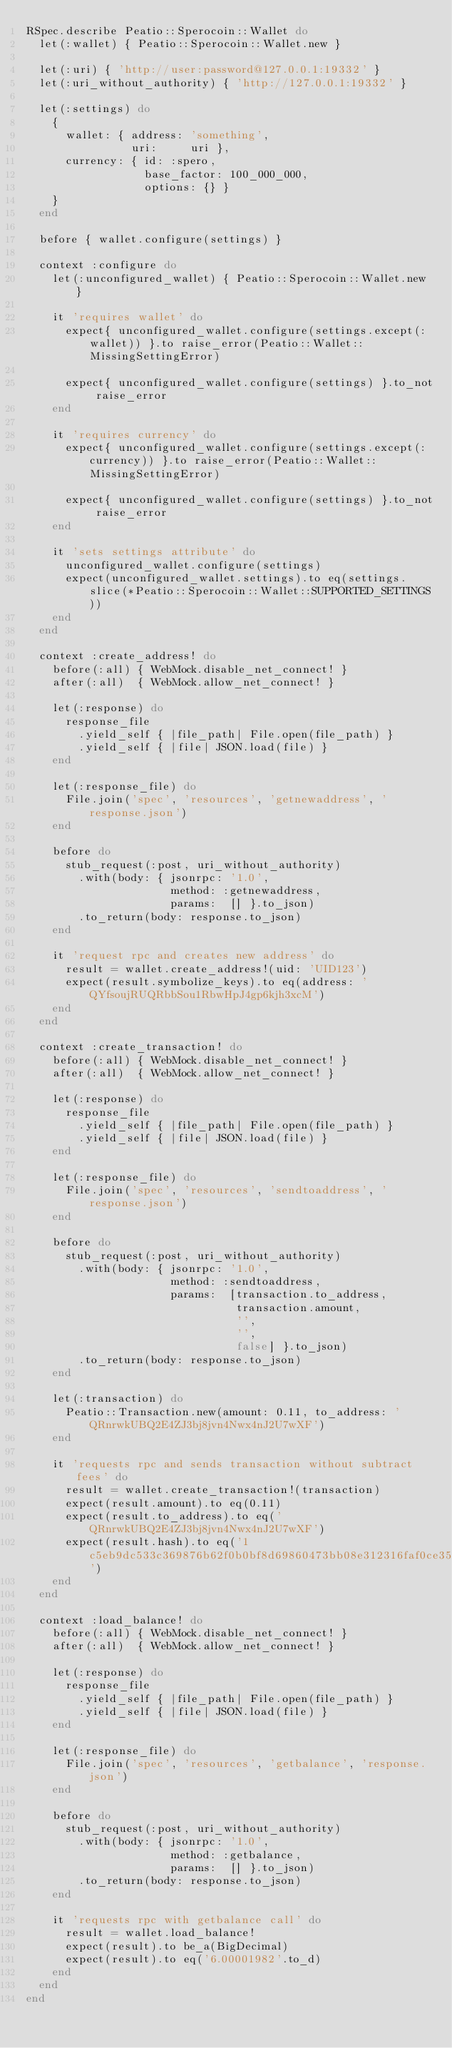<code> <loc_0><loc_0><loc_500><loc_500><_Ruby_>RSpec.describe Peatio::Sperocoin::Wallet do
  let(:wallet) { Peatio::Sperocoin::Wallet.new }

  let(:uri) { 'http://user:password@127.0.0.1:19332' }
  let(:uri_without_authority) { 'http://127.0.0.1:19332' }

  let(:settings) do
    {
      wallet: { address: 'something',
                uri:     uri },
      currency: { id: :spero,
                  base_factor: 100_000_000,
                  options: {} }
    }
  end

  before { wallet.configure(settings) }

  context :configure do
    let(:unconfigured_wallet) { Peatio::Sperocoin::Wallet.new }

    it 'requires wallet' do
      expect{ unconfigured_wallet.configure(settings.except(:wallet)) }.to raise_error(Peatio::Wallet::MissingSettingError)

      expect{ unconfigured_wallet.configure(settings) }.to_not raise_error
    end

    it 'requires currency' do
      expect{ unconfigured_wallet.configure(settings.except(:currency)) }.to raise_error(Peatio::Wallet::MissingSettingError)

      expect{ unconfigured_wallet.configure(settings) }.to_not raise_error
    end

    it 'sets settings attribute' do
      unconfigured_wallet.configure(settings)
      expect(unconfigured_wallet.settings).to eq(settings.slice(*Peatio::Sperocoin::Wallet::SUPPORTED_SETTINGS))
    end
  end

  context :create_address! do
    before(:all) { WebMock.disable_net_connect! }
    after(:all)  { WebMock.allow_net_connect! }

    let(:response) do
      response_file
        .yield_self { |file_path| File.open(file_path) }
        .yield_self { |file| JSON.load(file) }
    end

    let(:response_file) do
      File.join('spec', 'resources', 'getnewaddress', 'response.json')
    end

    before do
      stub_request(:post, uri_without_authority)
        .with(body: { jsonrpc: '1.0',
                      method: :getnewaddress,
                      params:  [] }.to_json)
        .to_return(body: response.to_json)
    end

    it 'request rpc and creates new address' do
      result = wallet.create_address!(uid: 'UID123')
      expect(result.symbolize_keys).to eq(address: 'QYfsoujRUQRbbSou1RbwHpJ4gp6kjh3xcM')
    end
  end

  context :create_transaction! do
    before(:all) { WebMock.disable_net_connect! }
    after(:all)  { WebMock.allow_net_connect! }

    let(:response) do
      response_file
        .yield_self { |file_path| File.open(file_path) }
        .yield_self { |file| JSON.load(file) }
    end

    let(:response_file) do
      File.join('spec', 'resources', 'sendtoaddress', 'response.json')
    end

    before do
      stub_request(:post, uri_without_authority)
        .with(body: { jsonrpc: '1.0',
                      method: :sendtoaddress,
                      params:  [transaction.to_address,
                                transaction.amount,
                                '',
                                '',
                                false] }.to_json)
        .to_return(body: response.to_json)
    end

    let(:transaction) do
      Peatio::Transaction.new(amount: 0.11, to_address: 'QRnrwkUBQ2E4ZJ3bj8jvn4Nwx4nJ2U7wXF')
    end

    it 'requests rpc and sends transaction without subtract fees' do
      result = wallet.create_transaction!(transaction)
      expect(result.amount).to eq(0.11)
      expect(result.to_address).to eq('QRnrwkUBQ2E4ZJ3bj8jvn4Nwx4nJ2U7wXF')
      expect(result.hash).to eq('1c5eb9dc533c369876b62f0b0bf8d69860473bb08e312316faf0ce35f2126fd7')
    end
  end

  context :load_balance! do
    before(:all) { WebMock.disable_net_connect! }
    after(:all)  { WebMock.allow_net_connect! }

    let(:response) do
      response_file
        .yield_self { |file_path| File.open(file_path) }
        .yield_self { |file| JSON.load(file) }
    end

    let(:response_file) do
      File.join('spec', 'resources', 'getbalance', 'response.json')
    end

    before do
      stub_request(:post, uri_without_authority)
        .with(body: { jsonrpc: '1.0',
                      method: :getbalance,
                      params:  [] }.to_json)
        .to_return(body: response.to_json)
    end

    it 'requests rpc with getbalance call' do
      result = wallet.load_balance!
      expect(result).to be_a(BigDecimal)
      expect(result).to eq('6.00001982'.to_d)
    end
  end
end
</code> 